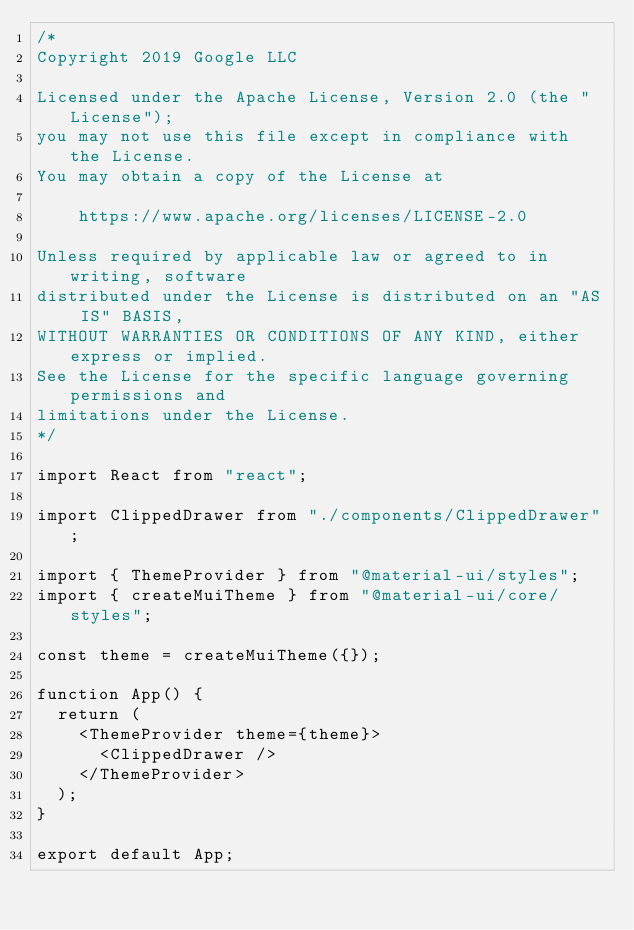<code> <loc_0><loc_0><loc_500><loc_500><_JavaScript_>/*
Copyright 2019 Google LLC

Licensed under the Apache License, Version 2.0 (the "License");
you may not use this file except in compliance with the License.
You may obtain a copy of the License at

    https://www.apache.org/licenses/LICENSE-2.0

Unless required by applicable law or agreed to in writing, software
distributed under the License is distributed on an "AS IS" BASIS,
WITHOUT WARRANTIES OR CONDITIONS OF ANY KIND, either express or implied.
See the License for the specific language governing permissions and
limitations under the License.
*/

import React from "react";

import ClippedDrawer from "./components/ClippedDrawer";

import { ThemeProvider } from "@material-ui/styles";
import { createMuiTheme } from "@material-ui/core/styles";

const theme = createMuiTheme({});

function App() {
  return (
    <ThemeProvider theme={theme}>
      <ClippedDrawer />
    </ThemeProvider>
  );
}

export default App;
</code> 